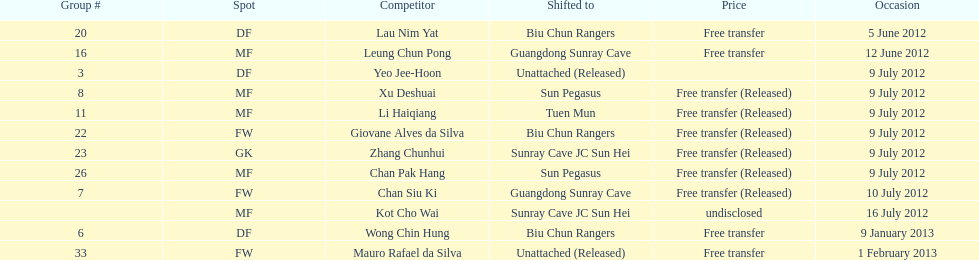What position is next to squad # 3? DF. 